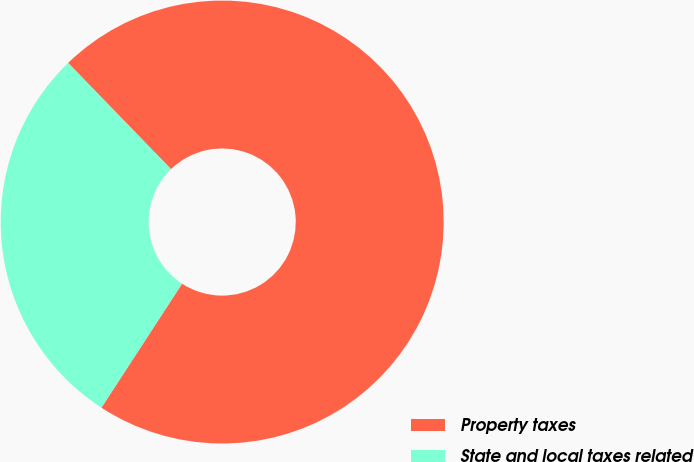<chart> <loc_0><loc_0><loc_500><loc_500><pie_chart><fcel>Property taxes<fcel>State and local taxes related<nl><fcel>71.43%<fcel>28.57%<nl></chart> 